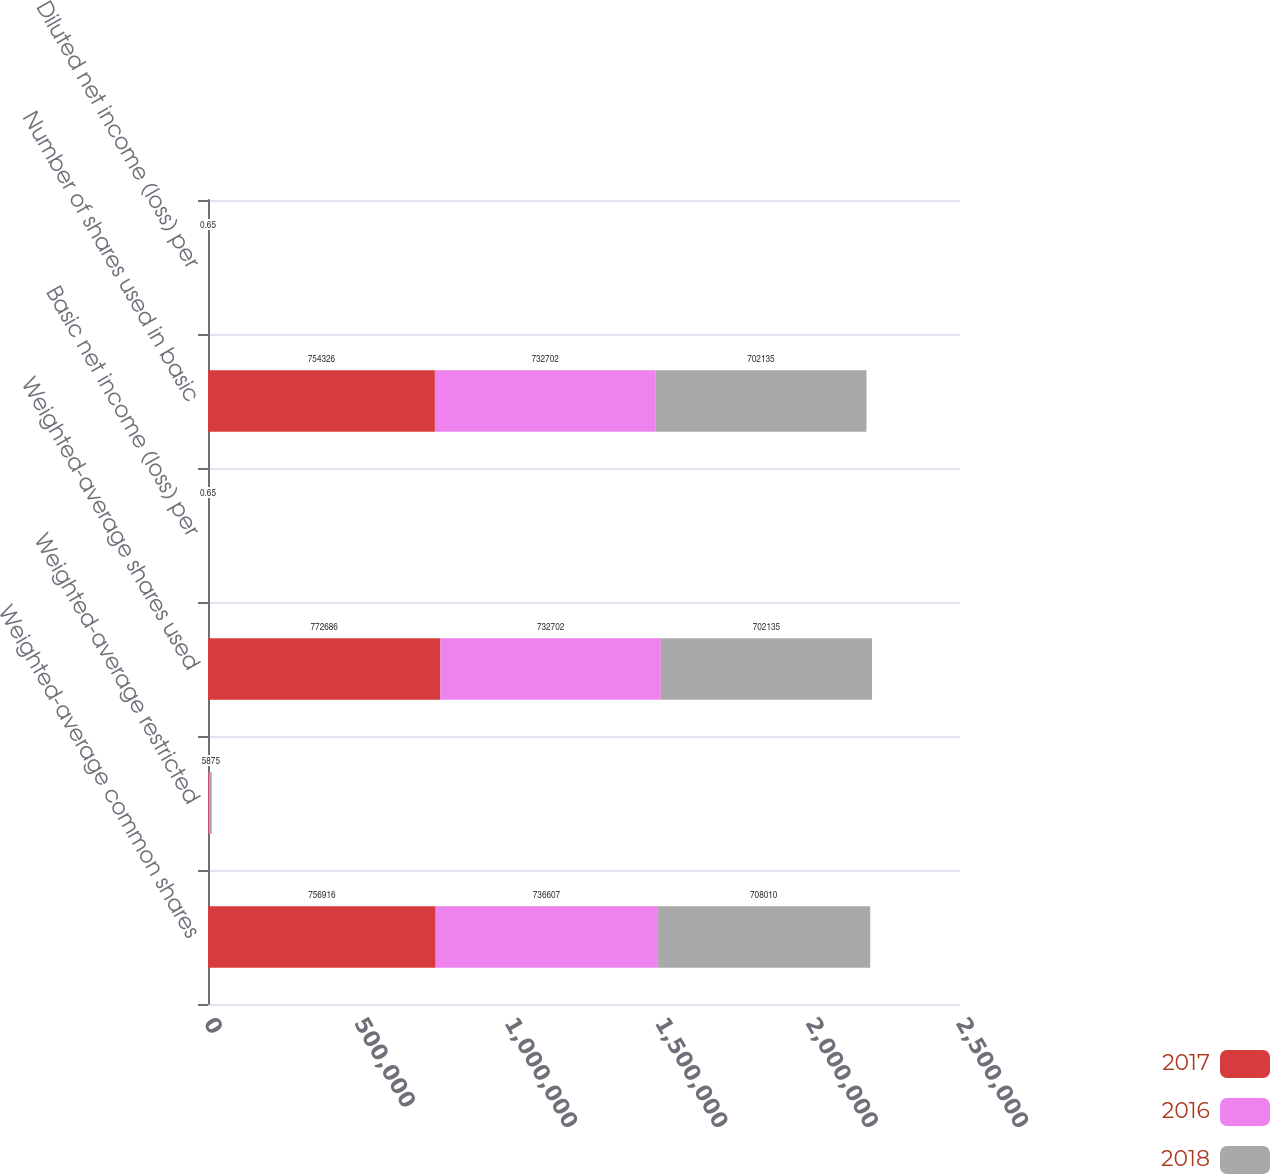<chart> <loc_0><loc_0><loc_500><loc_500><stacked_bar_chart><ecel><fcel>Weighted-average common shares<fcel>Weighted-average restricted<fcel>Weighted-average shares used<fcel>Basic net income (loss) per<fcel>Number of shares used in basic<fcel>Diluted net income (loss) per<nl><fcel>2017<fcel>756916<fcel>2590<fcel>772686<fcel>1.6<fcel>754326<fcel>1.56<nl><fcel>2016<fcel>736607<fcel>3905<fcel>732702<fcel>0.15<fcel>732702<fcel>0.15<nl><fcel>2018<fcel>708010<fcel>5875<fcel>702135<fcel>0.65<fcel>702135<fcel>0.65<nl></chart> 